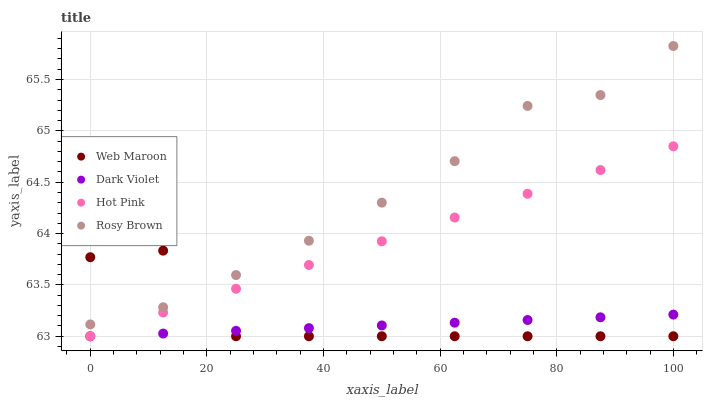Does Dark Violet have the minimum area under the curve?
Answer yes or no. Yes. Does Rosy Brown have the maximum area under the curve?
Answer yes or no. Yes. Does Hot Pink have the minimum area under the curve?
Answer yes or no. No. Does Hot Pink have the maximum area under the curve?
Answer yes or no. No. Is Dark Violet the smoothest?
Answer yes or no. Yes. Is Web Maroon the roughest?
Answer yes or no. Yes. Is Hot Pink the smoothest?
Answer yes or no. No. Is Hot Pink the roughest?
Answer yes or no. No. Does Hot Pink have the lowest value?
Answer yes or no. Yes. Does Rosy Brown have the highest value?
Answer yes or no. Yes. Does Hot Pink have the highest value?
Answer yes or no. No. Is Dark Violet less than Rosy Brown?
Answer yes or no. Yes. Is Rosy Brown greater than Dark Violet?
Answer yes or no. Yes. Does Rosy Brown intersect Web Maroon?
Answer yes or no. Yes. Is Rosy Brown less than Web Maroon?
Answer yes or no. No. Is Rosy Brown greater than Web Maroon?
Answer yes or no. No. Does Dark Violet intersect Rosy Brown?
Answer yes or no. No. 